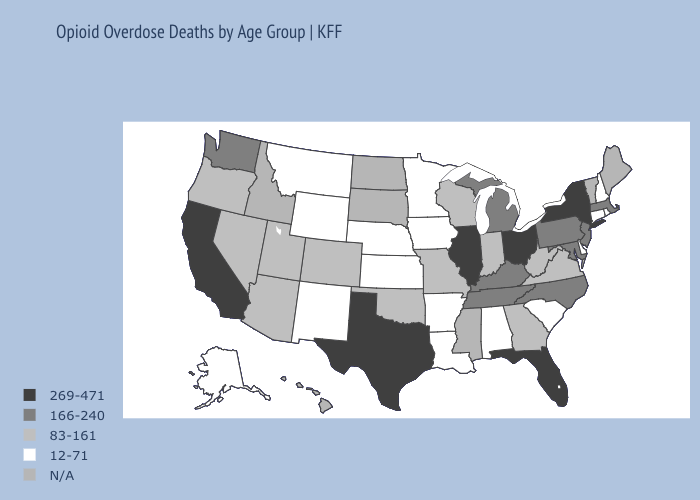Name the states that have a value in the range 269-471?
Concise answer only. California, Florida, Illinois, New York, Ohio, Texas. Among the states that border Kentucky , does Ohio have the highest value?
Concise answer only. Yes. Name the states that have a value in the range 12-71?
Write a very short answer. Alabama, Alaska, Arkansas, Connecticut, Delaware, Iowa, Kansas, Louisiana, Minnesota, Montana, Nebraska, New Hampshire, New Mexico, Rhode Island, South Carolina, Wyoming. Among the states that border West Virginia , does Virginia have the lowest value?
Keep it brief. Yes. Which states have the lowest value in the USA?
Keep it brief. Alabama, Alaska, Arkansas, Connecticut, Delaware, Iowa, Kansas, Louisiana, Minnesota, Montana, Nebraska, New Hampshire, New Mexico, Rhode Island, South Carolina, Wyoming. Which states have the lowest value in the South?
Short answer required. Alabama, Arkansas, Delaware, Louisiana, South Carolina. Among the states that border Vermont , does New York have the lowest value?
Keep it brief. No. What is the highest value in states that border Michigan?
Concise answer only. 269-471. Among the states that border Mississippi , does Arkansas have the highest value?
Short answer required. No. What is the value of Oklahoma?
Give a very brief answer. 83-161. Name the states that have a value in the range N/A?
Write a very short answer. Hawaii, Idaho, Maine, Mississippi, North Dakota, South Dakota, Vermont. Name the states that have a value in the range 83-161?
Concise answer only. Arizona, Colorado, Georgia, Indiana, Missouri, Nevada, Oklahoma, Oregon, Utah, Virginia, West Virginia, Wisconsin. What is the highest value in states that border Tennessee?
Short answer required. 166-240. 